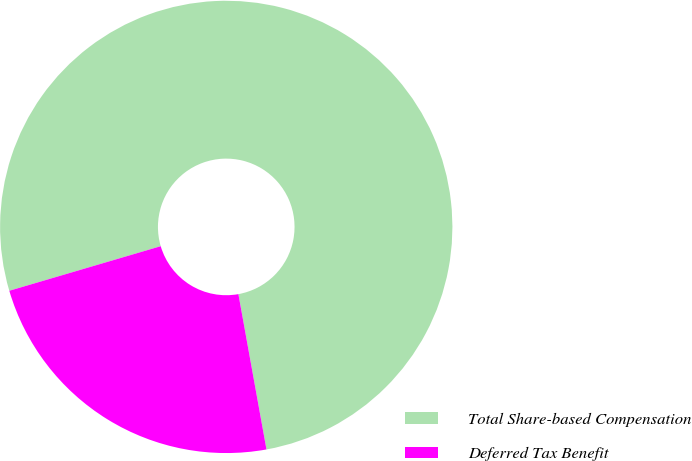<chart> <loc_0><loc_0><loc_500><loc_500><pie_chart><fcel>Total Share-based Compensation<fcel>Deferred Tax Benefit<nl><fcel>76.71%<fcel>23.29%<nl></chart> 